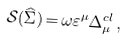<formula> <loc_0><loc_0><loc_500><loc_500>\mathcal { S } ( \widehat { \Sigma } ) \, \mathcal { = \, } \omega \varepsilon ^ { \mu } \Delta _ { \mu } ^ { c l } \, ,</formula> 